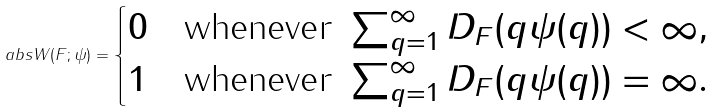<formula> <loc_0><loc_0><loc_500><loc_500>\ a b s { W ( F ; \psi ) } = \begin{cases} 0 & \text {whenever } \sum _ { q = 1 } ^ { \infty } D _ { F } ( q \psi ( q ) ) < \infty , \\ 1 & \text {whenever } \sum _ { q = 1 } ^ { \infty } D _ { F } ( q \psi ( q ) ) = \infty . \end{cases}</formula> 